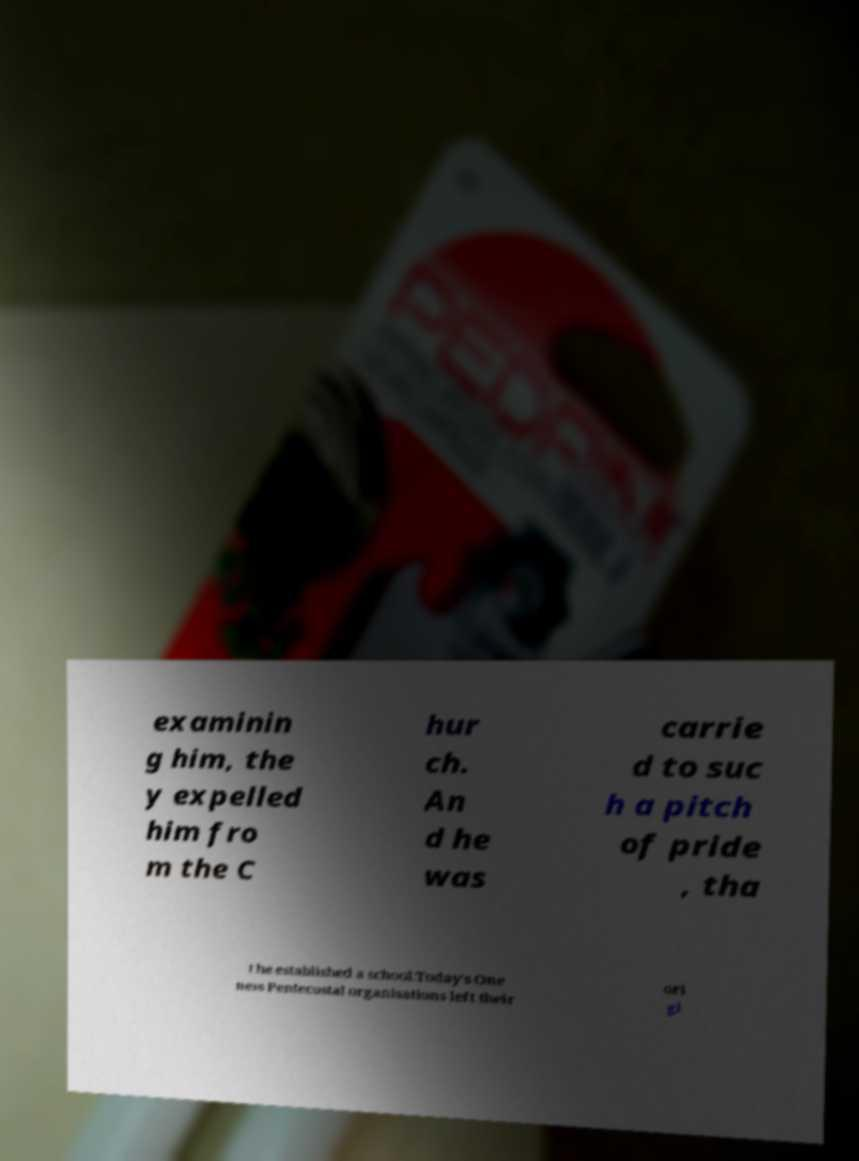Can you read and provide the text displayed in the image?This photo seems to have some interesting text. Can you extract and type it out for me? examinin g him, the y expelled him fro m the C hur ch. An d he was carrie d to suc h a pitch of pride , tha t he established a school.Today's One ness Pentecostal organisations left their ori gi 